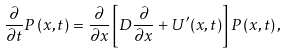<formula> <loc_0><loc_0><loc_500><loc_500>\frac { \partial } { \partial t } P \left ( x , t \right ) = \frac { \partial } { \partial x } \left [ D \frac { \partial } { \partial x } + U ^ { \prime } ( x , t ) \right ] P \left ( x , t \right ) ,</formula> 